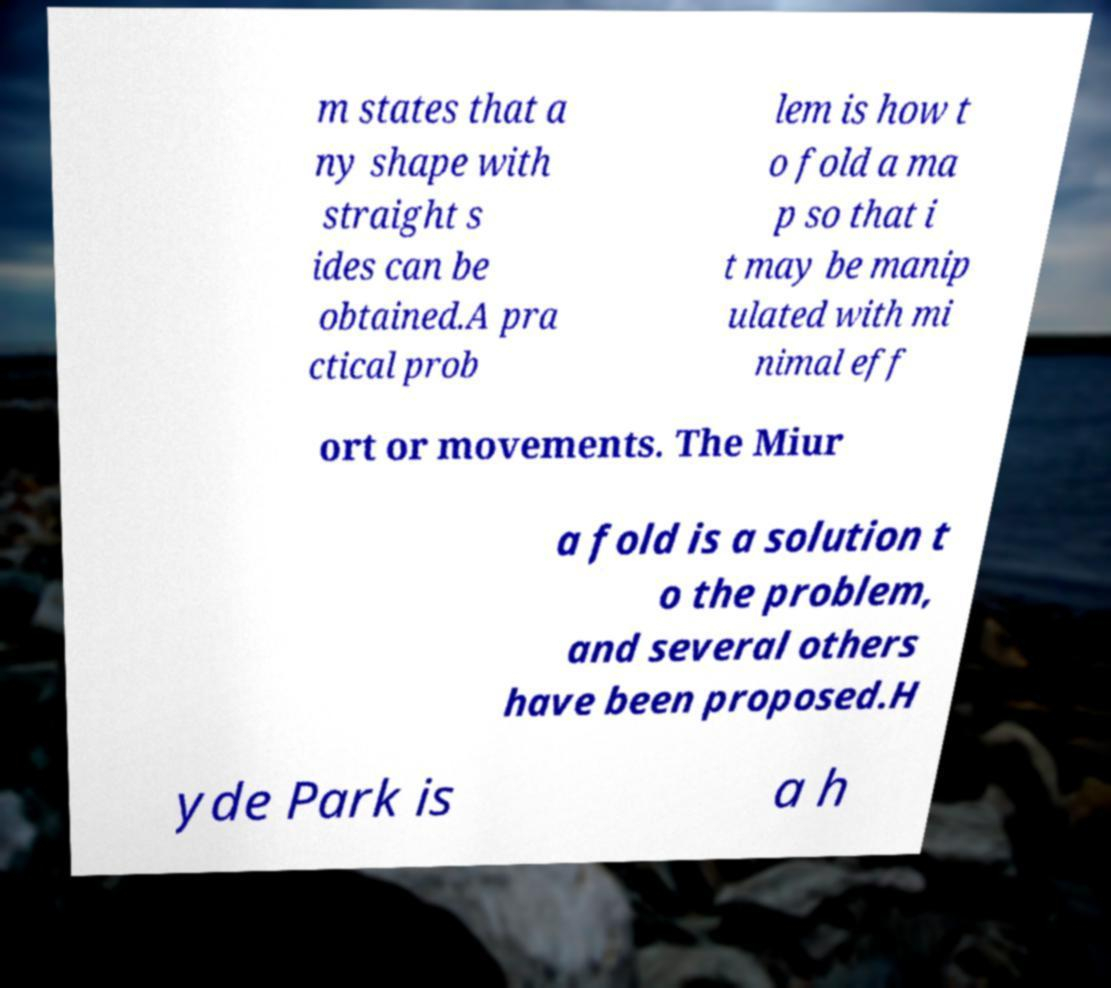Could you assist in decoding the text presented in this image and type it out clearly? m states that a ny shape with straight s ides can be obtained.A pra ctical prob lem is how t o fold a ma p so that i t may be manip ulated with mi nimal eff ort or movements. The Miur a fold is a solution t o the problem, and several others have been proposed.H yde Park is a h 